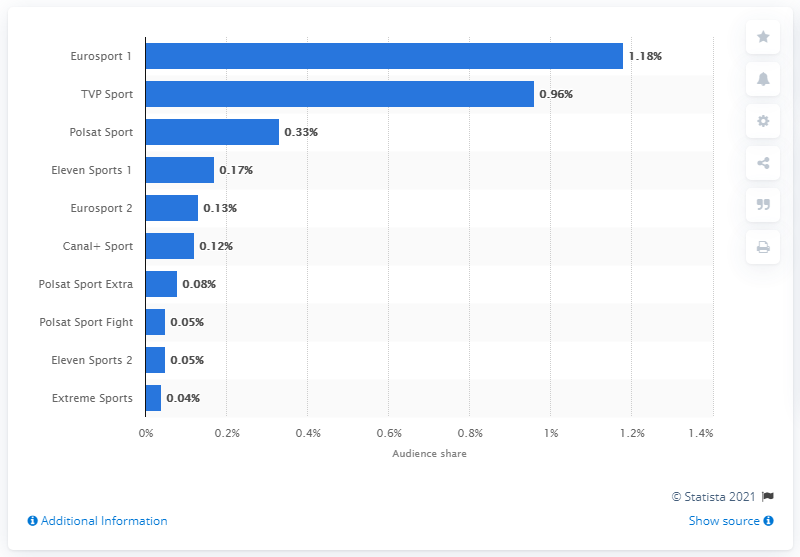List a handful of essential elements in this visual. In January 2021, Eurosport 1 was the leading sports television channel in Poland. 